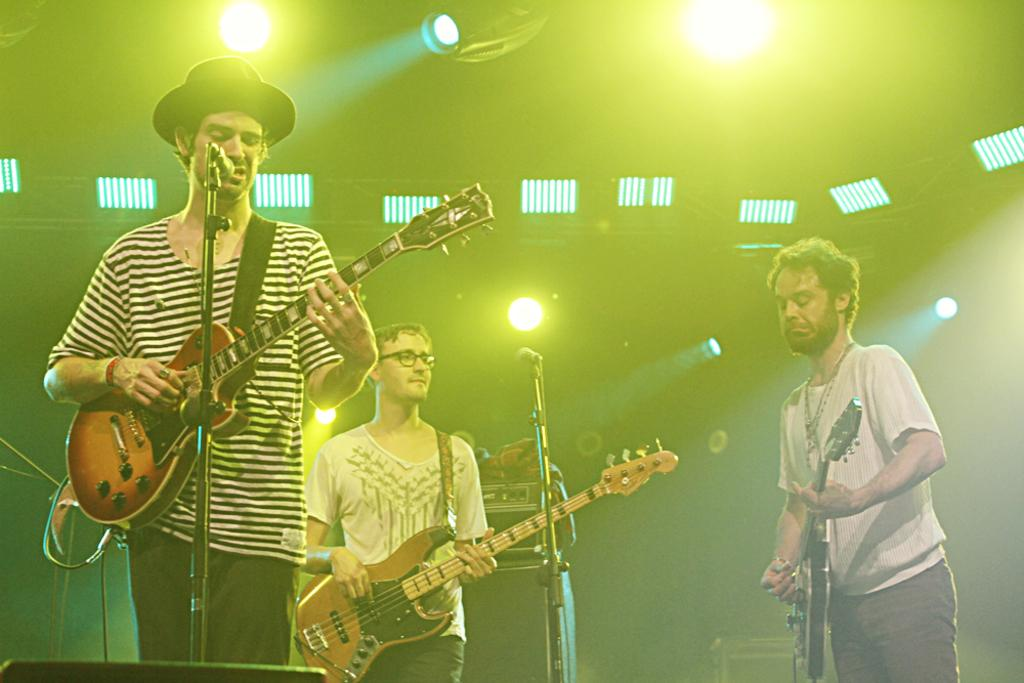How many people are in the image? There are three persons in the image. What are the persons doing in the image? The persons are playing musical instruments. What objects are in front of the persons? There are microphones in front of the persons. What can be seen in the background of the image? There are lights visible in the background of the image. Can you see a giraffe playing a musical instrument in the image? No, there is no giraffe present in the image. What type of cap is the person wearing while playing the instrument? There is no cap mentioned or visible in the image. 